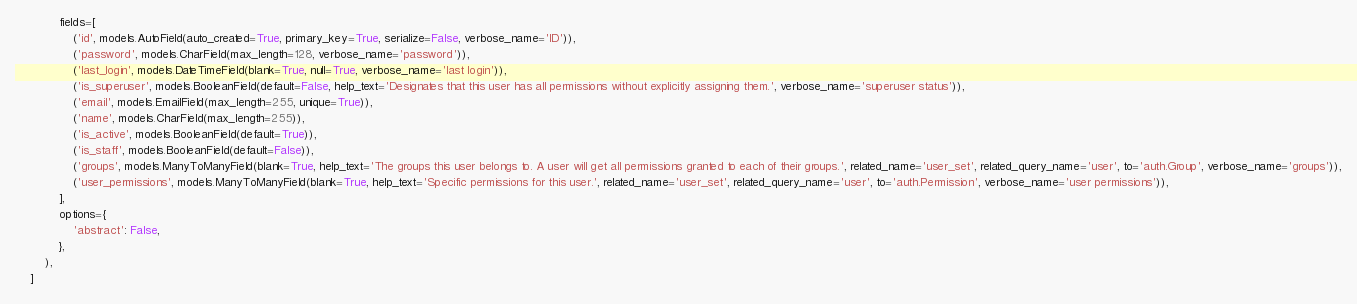Convert code to text. <code><loc_0><loc_0><loc_500><loc_500><_Python_>            fields=[
                ('id', models.AutoField(auto_created=True, primary_key=True, serialize=False, verbose_name='ID')),
                ('password', models.CharField(max_length=128, verbose_name='password')),
                ('last_login', models.DateTimeField(blank=True, null=True, verbose_name='last login')),
                ('is_superuser', models.BooleanField(default=False, help_text='Designates that this user has all permissions without explicitly assigning them.', verbose_name='superuser status')),
                ('email', models.EmailField(max_length=255, unique=True)),
                ('name', models.CharField(max_length=255)),
                ('is_active', models.BooleanField(default=True)),
                ('is_staff', models.BooleanField(default=False)),
                ('groups', models.ManyToManyField(blank=True, help_text='The groups this user belongs to. A user will get all permissions granted to each of their groups.', related_name='user_set', related_query_name='user', to='auth.Group', verbose_name='groups')),
                ('user_permissions', models.ManyToManyField(blank=True, help_text='Specific permissions for this user.', related_name='user_set', related_query_name='user', to='auth.Permission', verbose_name='user permissions')),
            ],
            options={
                'abstract': False,
            },
        ),
    ]
</code> 